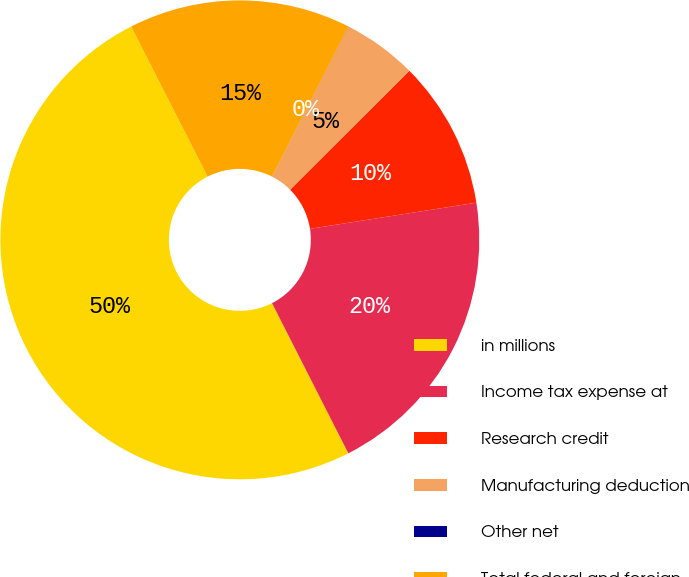Convert chart. <chart><loc_0><loc_0><loc_500><loc_500><pie_chart><fcel>in millions<fcel>Income tax expense at<fcel>Research credit<fcel>Manufacturing deduction<fcel>Other net<fcel>Total federal and foreign<nl><fcel>49.98%<fcel>20.0%<fcel>10.0%<fcel>5.01%<fcel>0.01%<fcel>15.0%<nl></chart> 